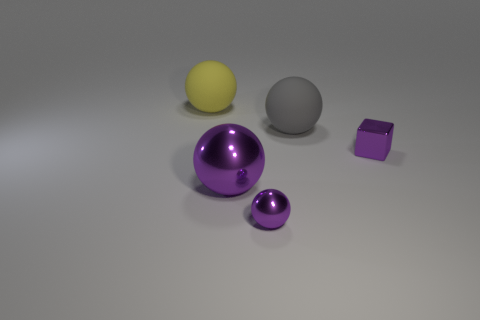Add 2 big metal objects. How many objects exist? 7 Subtract all cubes. How many objects are left? 4 Add 2 large purple objects. How many large purple objects are left? 3 Add 1 small blue rubber spheres. How many small blue rubber spheres exist? 1 Subtract 0 brown blocks. How many objects are left? 5 Subtract all tiny metallic cubes. Subtract all big purple spheres. How many objects are left? 3 